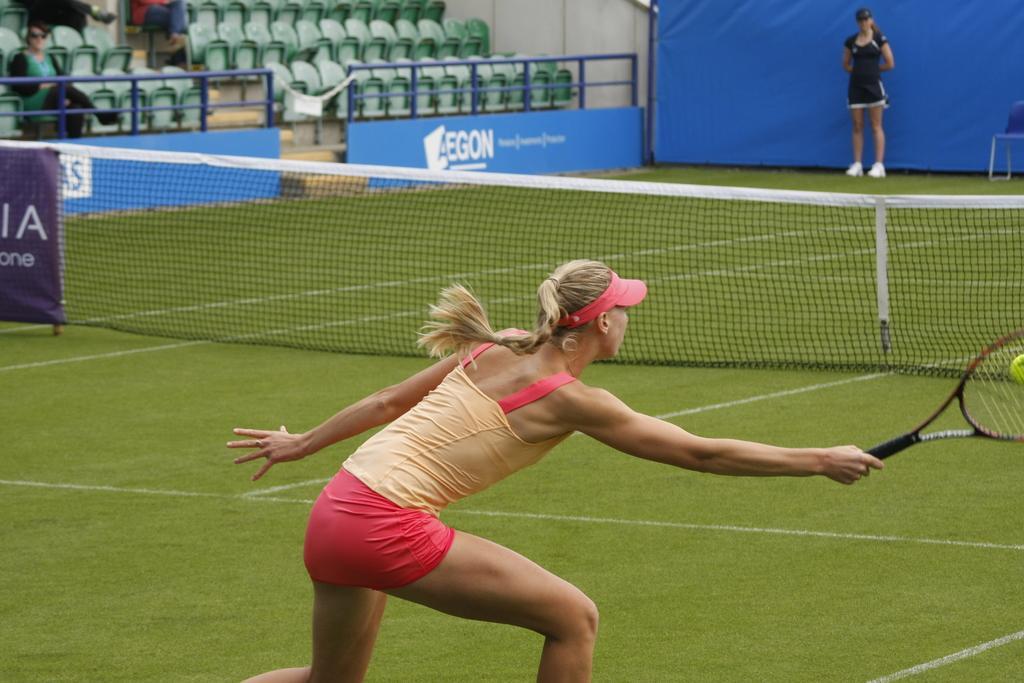How would you summarize this image in a sentence or two? In the image we can see there is a woman who is standing with the tennis racket and hitting a ball and in front of her there is a net and on the other side there is another woman who is standing and the people are sitting on chair. 